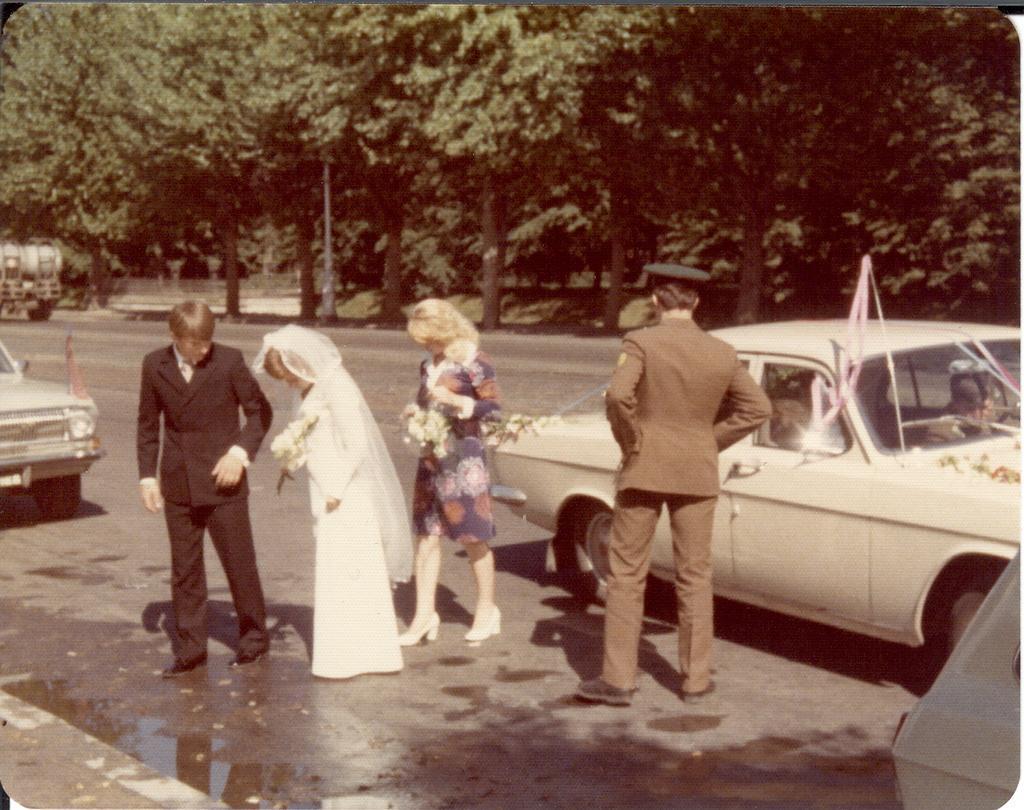Can you describe this image briefly? In the center of the image a man is standing and two ladies are walking and holding bouquet. On the right side of the image we can see a car and a man is standing and wearing hat. On the left side of the image we can see car and a vehicle. In the background of the image we can see trees, pole. In the middle of the image we can see a road. 